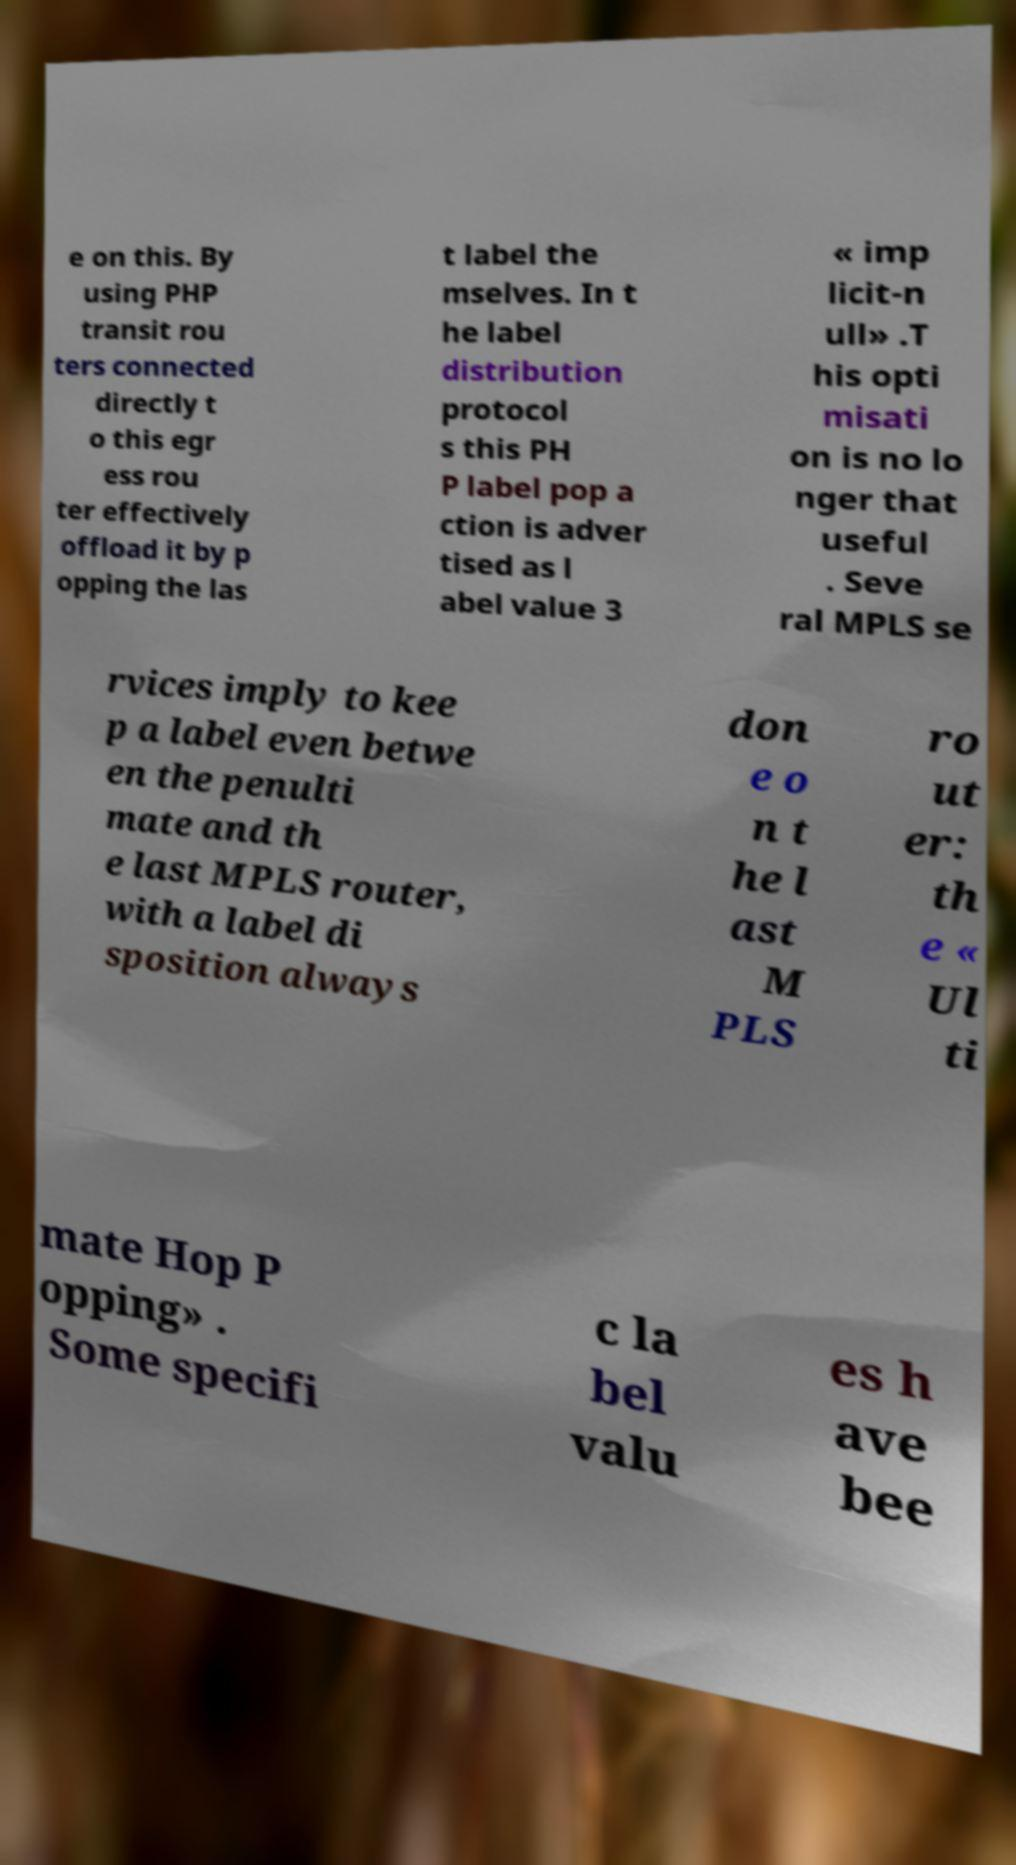Please identify and transcribe the text found in this image. e on this. By using PHP transit rou ters connected directly t o this egr ess rou ter effectively offload it by p opping the las t label the mselves. In t he label distribution protocol s this PH P label pop a ction is adver tised as l abel value 3 « imp licit-n ull» .T his opti misati on is no lo nger that useful . Seve ral MPLS se rvices imply to kee p a label even betwe en the penulti mate and th e last MPLS router, with a label di sposition always don e o n t he l ast M PLS ro ut er: th e « Ul ti mate Hop P opping» . Some specifi c la bel valu es h ave bee 